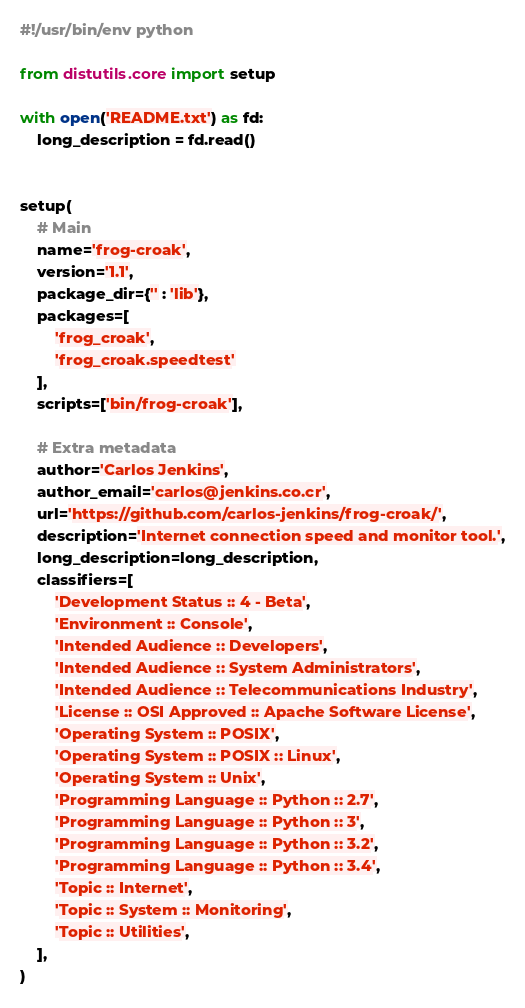<code> <loc_0><loc_0><loc_500><loc_500><_Python_>#!/usr/bin/env python

from distutils.core import setup

with open('README.txt') as fd:
    long_description = fd.read()


setup(
    # Main
    name='frog-croak',
    version='1.1',
    package_dir={'' : 'lib'},
    packages=[
        'frog_croak',
        'frog_croak.speedtest'
    ],
    scripts=['bin/frog-croak'],

    # Extra metadata
    author='Carlos Jenkins',
    author_email='carlos@jenkins.co.cr',
    url='https://github.com/carlos-jenkins/frog-croak/',
    description='Internet connection speed and monitor tool.',
    long_description=long_description,
    classifiers=[
        'Development Status :: 4 - Beta',
        'Environment :: Console',
        'Intended Audience :: Developers',
        'Intended Audience :: System Administrators',
        'Intended Audience :: Telecommunications Industry',
        'License :: OSI Approved :: Apache Software License',
        'Operating System :: POSIX',
        'Operating System :: POSIX :: Linux',
        'Operating System :: Unix',
        'Programming Language :: Python :: 2.7',
        'Programming Language :: Python :: 3',
        'Programming Language :: Python :: 3.2',
        'Programming Language :: Python :: 3.4',
        'Topic :: Internet',
        'Topic :: System :: Monitoring',
        'Topic :: Utilities',
    ],
)
</code> 